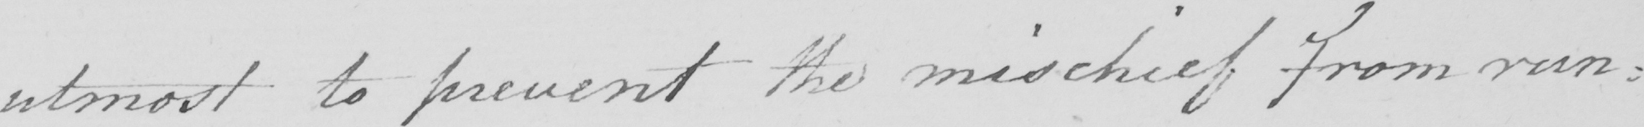What does this handwritten line say? utmost to prevent the mischief from run : 